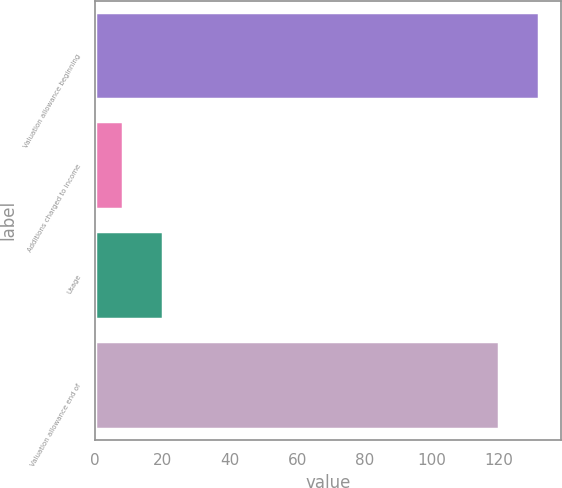<chart> <loc_0><loc_0><loc_500><loc_500><bar_chart><fcel>Valuation allowance beginning<fcel>Additions charged to income<fcel>Usage<fcel>Valuation allowance end of<nl><fcel>131.92<fcel>8.3<fcel>20.12<fcel>120.1<nl></chart> 